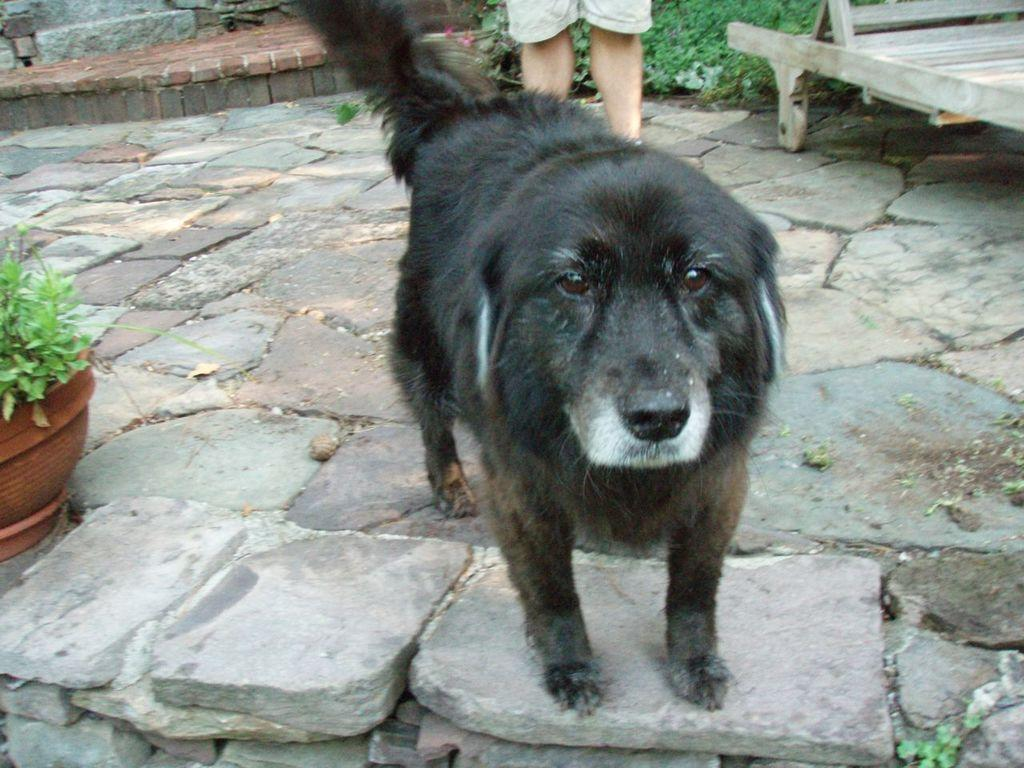What type of animal is in the image? There is a black dog in the image. Where is the dog located in the image? The dog is standing on the road. Is there anyone else present in the image? Yes, there is a person standing behind the dog. What type of ship can be seen in the image? There is no ship present in the image; it features a black dog standing on the road with a person behind it. What is the credit score of the person standing behind the dog? There is no information about the person's credit score in the image. 